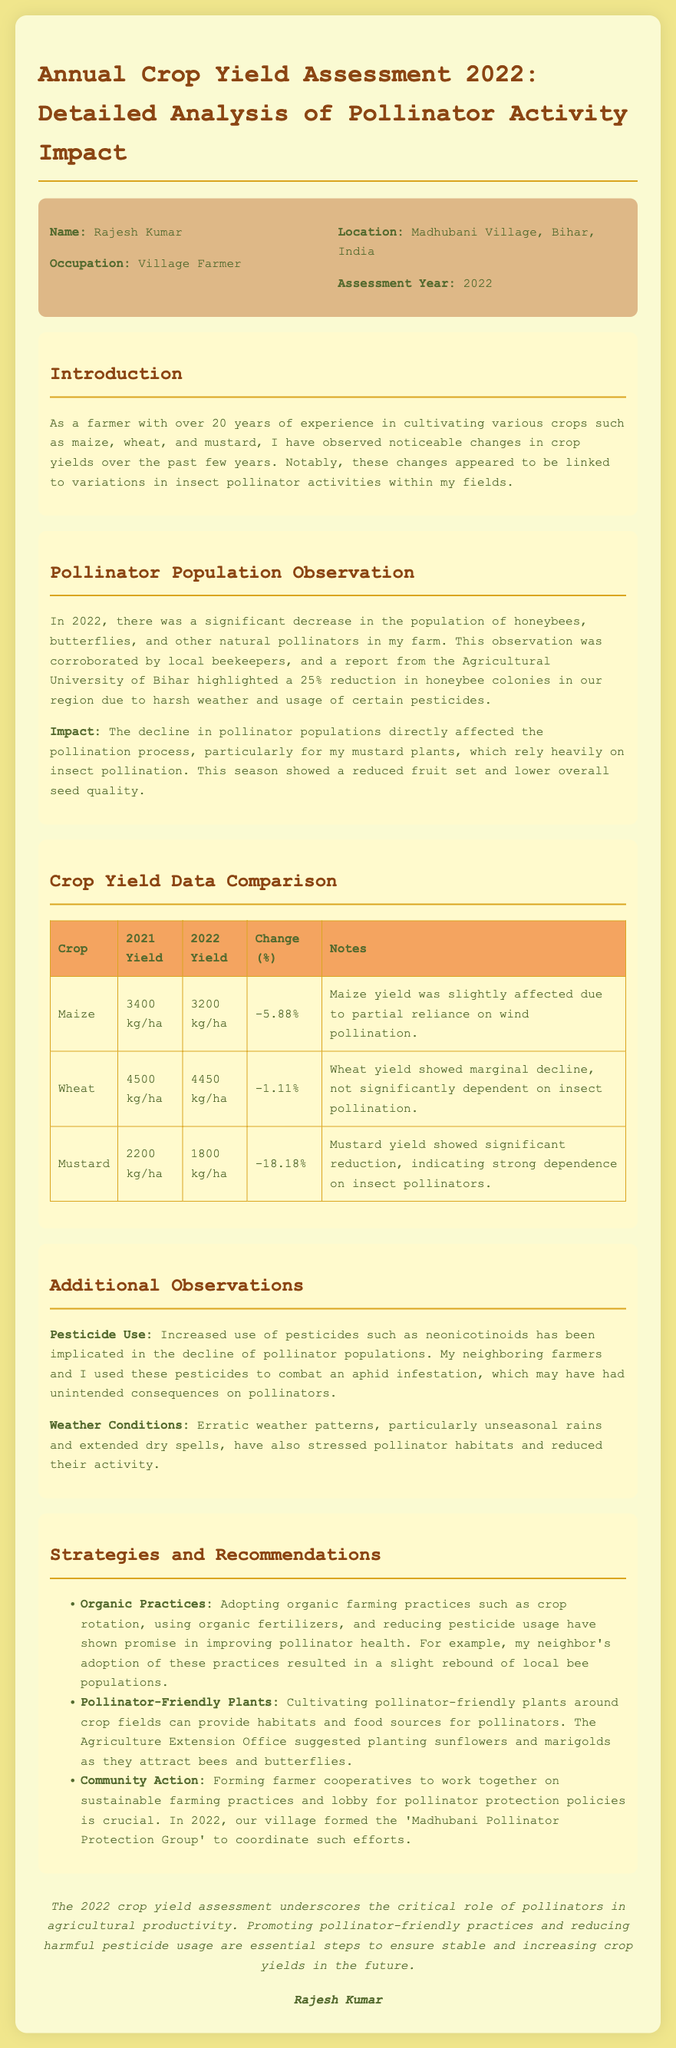What is the name of the farmer? The document states the farmer's name is Rajesh Kumar.
Answer: Rajesh Kumar What year is the assessment for? The assessment year mentioned in the document is 2022.
Answer: 2022 What was the yield of mustard in 2021? The document indicates that the mustard yield in 2021 was 2200 kg/ha.
Answer: 2200 kg/ha What percentage did the maize yield change in 2022? The document shows a -5.88% change in maize yield for 2022.
Answer: -5.88% What was the primary factor affecting mustard yield? The impact on mustard yield was primarily due to a decline in insect pollinators.
Answer: Insect pollinators What group was formed in 2022 for pollinator protection? The document mentions the formation of the 'Madhubani Pollinator Protection Group'.
Answer: Madhubani Pollinator Protection Group What pesticide was implicated in the decline of pollinator populations? The document identifies neonicotinoids as a pesticide linked to the decline.
Answer: Neonicotinoids What crop showed the most significant yield reduction? The document states that mustard showed the most significant reduction in yield.
Answer: Mustard What practice did the neighbor adopt that resulted in a rebound of bee populations? The document mentions that the neighbor adopted organic farming practices.
Answer: Organic farming practices 